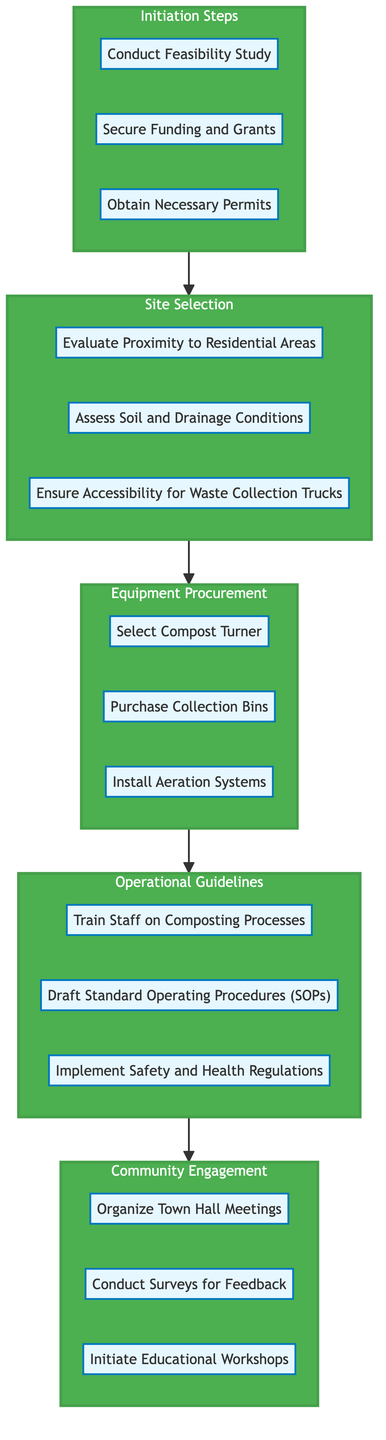What is the first step in the flowchart? The diagram indicates that the first step is "Conduct Feasibility Study" under the "Initiation Steps" section.
Answer: Conduct Feasibility Study How many substeps are in the "Operational Guidelines" section? The "Operational Guidelines" section contains three substeps: "Train Staff on Composting Processes," "Draft Standard Operating Procedures (SOPs)," and "Implement Safety and Health Regulations."
Answer: 3 What substep follows "Select Compost Turner"? The substep that follows "Select Compost Turner" is "Purchase Collection Bins." The flow of the diagram moves sequentially from equipment procurement.
Answer: Purchase Collection Bins Which section comes after "Site Selection" in the flowchart? After the "Site Selection" section, the next section is "Equipment Procurement," indicating a continuous flow towards the implementation process.
Answer: Equipment Procurement What are the three substeps listed under "Community Engagement"? The substeps under "Community Engagement" are: "Organize Town Hall Meetings," "Conduct Surveys for Feedback," and "Initiate Educational Workshops."
Answer: Organize Town Hall Meetings, Conduct Surveys for Feedback, Initiate Educational Workshops How many sections are there in total in the diagram? The diagram consists of five sections: "Initiation Steps," "Site Selection," "Equipment Procurement," "Operational Guidelines," and "Community Engagement."
Answer: 5 What is the last section in the flowchart? The last section in the flowchart is "Community Engagement," which indicates the final engagement with the community after operational guidelines are established.
Answer: Community Engagement What is the last substep in the "Site Selection" section? The last substep listed in the "Site Selection" section is "Ensure Accessibility for Waste Collection Trucks," which implies ensuring practical waste management solutions.
Answer: Ensure Accessibility for Waste Collection Trucks Which section flows directly into "Operational Guidelines"? The section that flows directly into "Operational Guidelines" is "Equipment Procurement," indicating the order of operations leading towards establishing guidelines for operation.
Answer: Equipment Procurement 